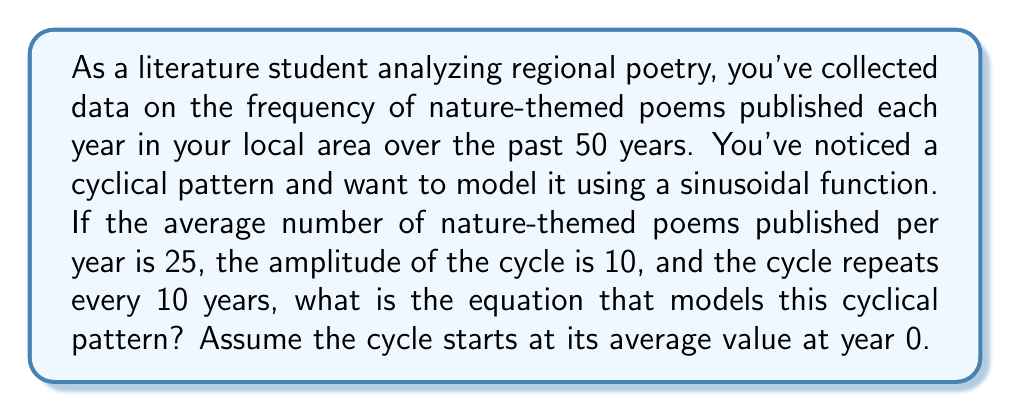What is the answer to this math problem? To model this cyclical pattern, we'll use a sinusoidal function of the form:

$$f(t) = A \sin(Bt - C) + D$$

Where:
- $A$ is the amplitude
- $B$ is the angular frequency
- $C$ is the phase shift
- $D$ is the vertical shift (average value)

Given information:
- Average number of poems (D): 25
- Amplitude (A): 10
- Cycle period: 10 years

Step 1: Calculate the angular frequency (B)
The angular frequency is given by $B = \frac{2\pi}{T}$, where T is the period.
$$B = \frac{2\pi}{10} = \frac{\pi}{5}$$

Step 2: Determine the phase shift (C)
Since the cycle starts at its average value at year 0, we need to shift the sine function by $\frac{\pi}{2}$ to the left. This means $C = \frac{\pi}{2}$.

Step 3: Construct the equation
Substituting the values into our general form:

$$f(t) = 10 \sin(\frac{\pi}{5}t - \frac{\pi}{2}) + 25$$

Step 4: Simplify
We can rewrite this using the cosine function to eliminate the phase shift:

$$f(t) = 10 \cos(\frac{\pi}{5}t) + 25$$

This equation models the cyclical pattern of nature-themed poems over time, where $t$ is the number of years since the start of the observation period.
Answer: $$f(t) = 10 \cos(\frac{\pi}{5}t) + 25$$ 